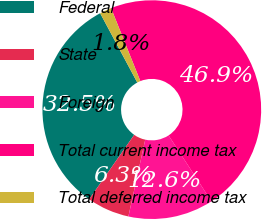Convert chart to OTSL. <chart><loc_0><loc_0><loc_500><loc_500><pie_chart><fcel>Federal<fcel>State<fcel>Foreign<fcel>Total current income tax<fcel>Total deferred income tax<nl><fcel>32.47%<fcel>6.27%<fcel>12.61%<fcel>46.9%<fcel>1.75%<nl></chart> 